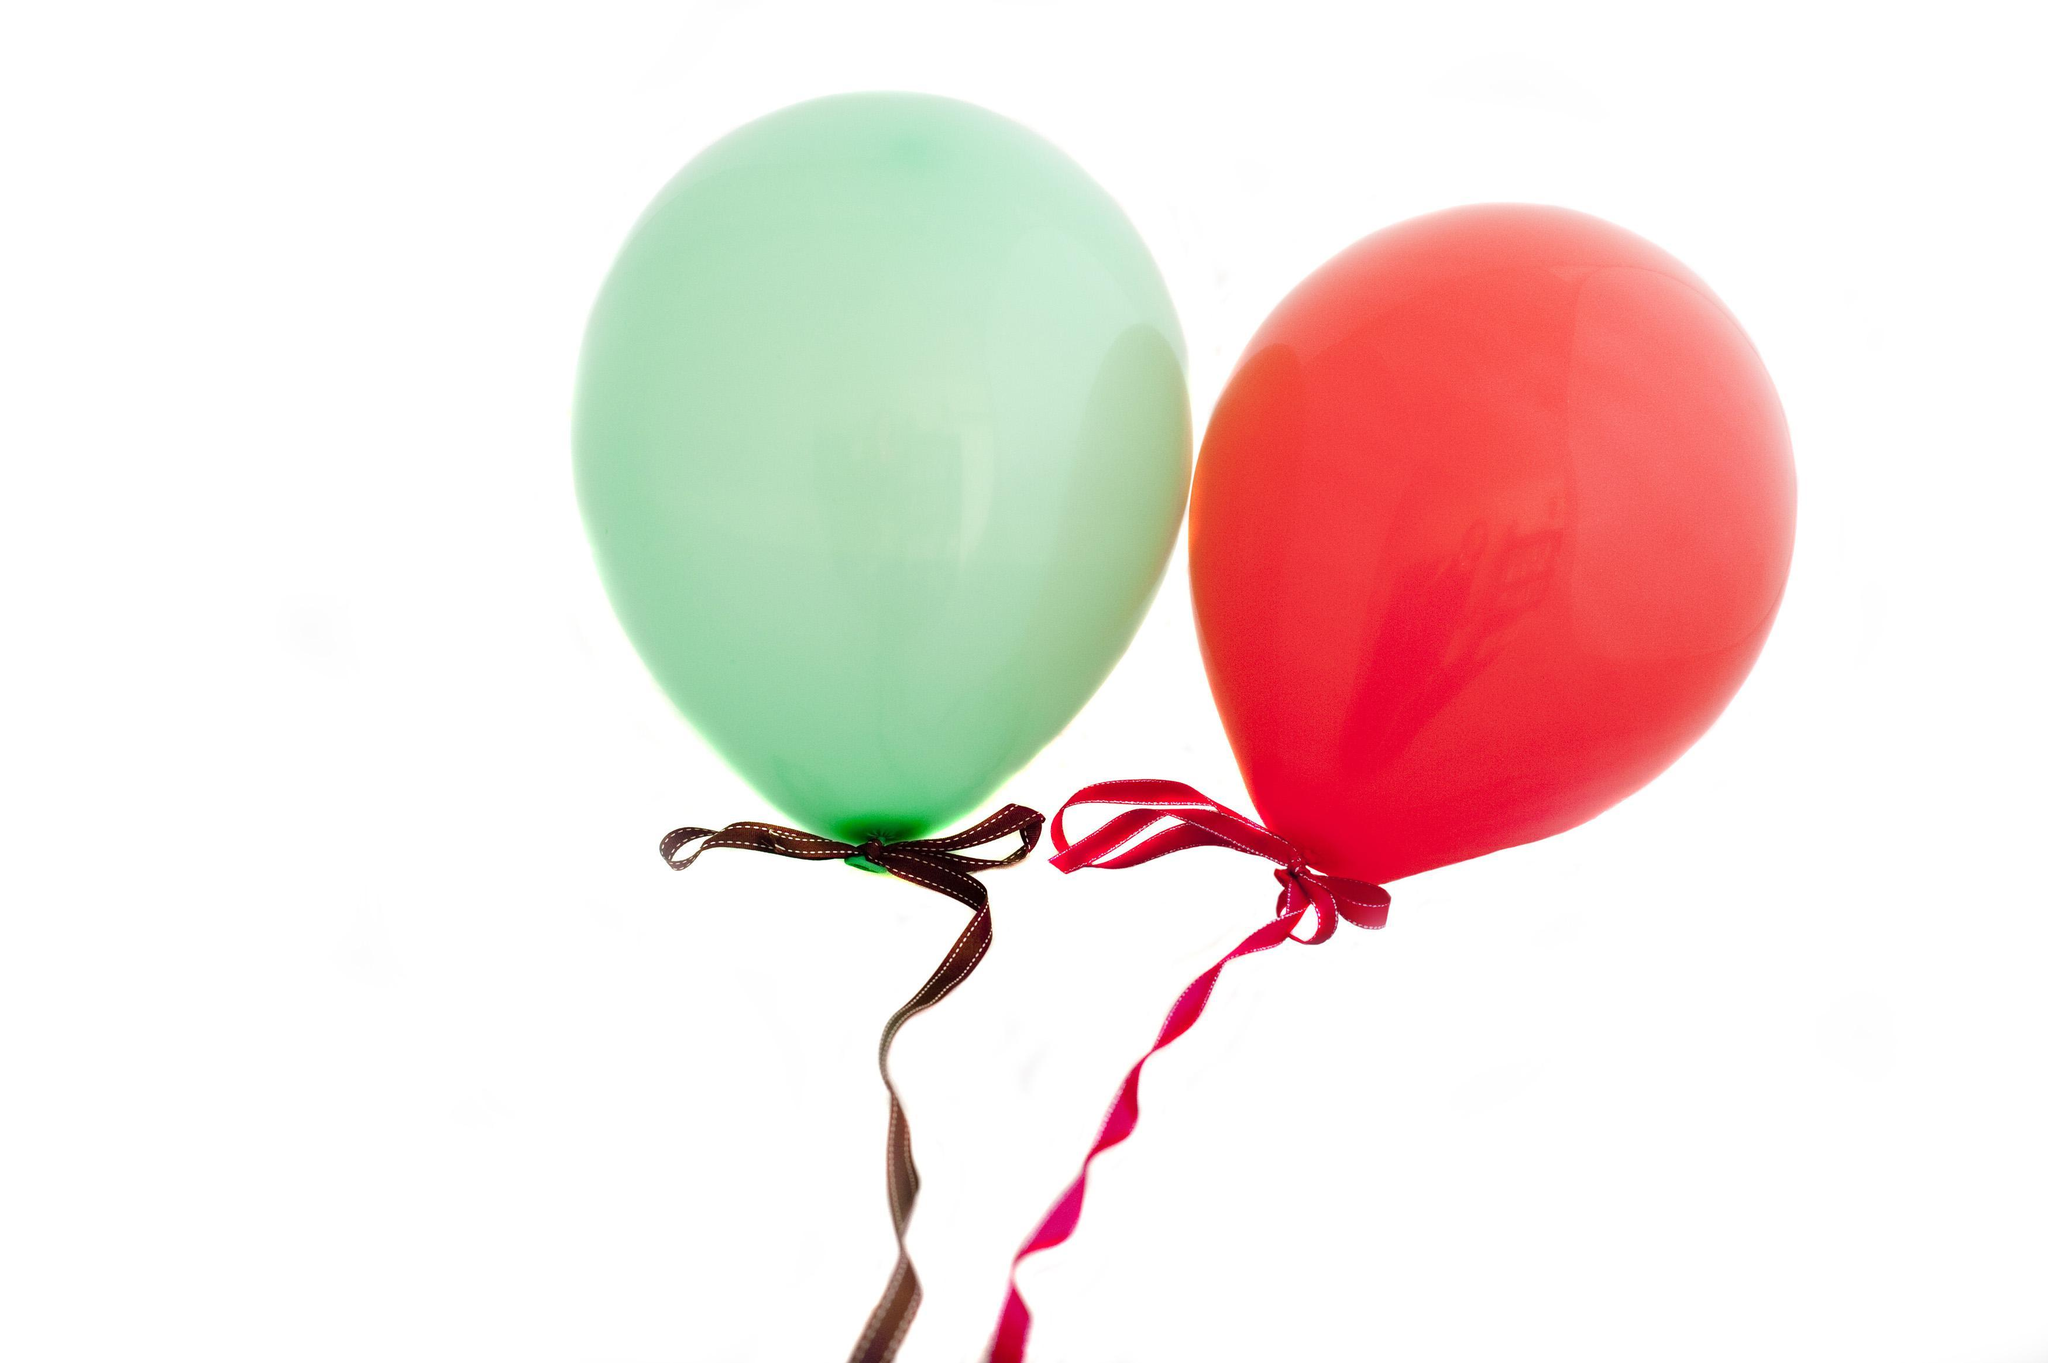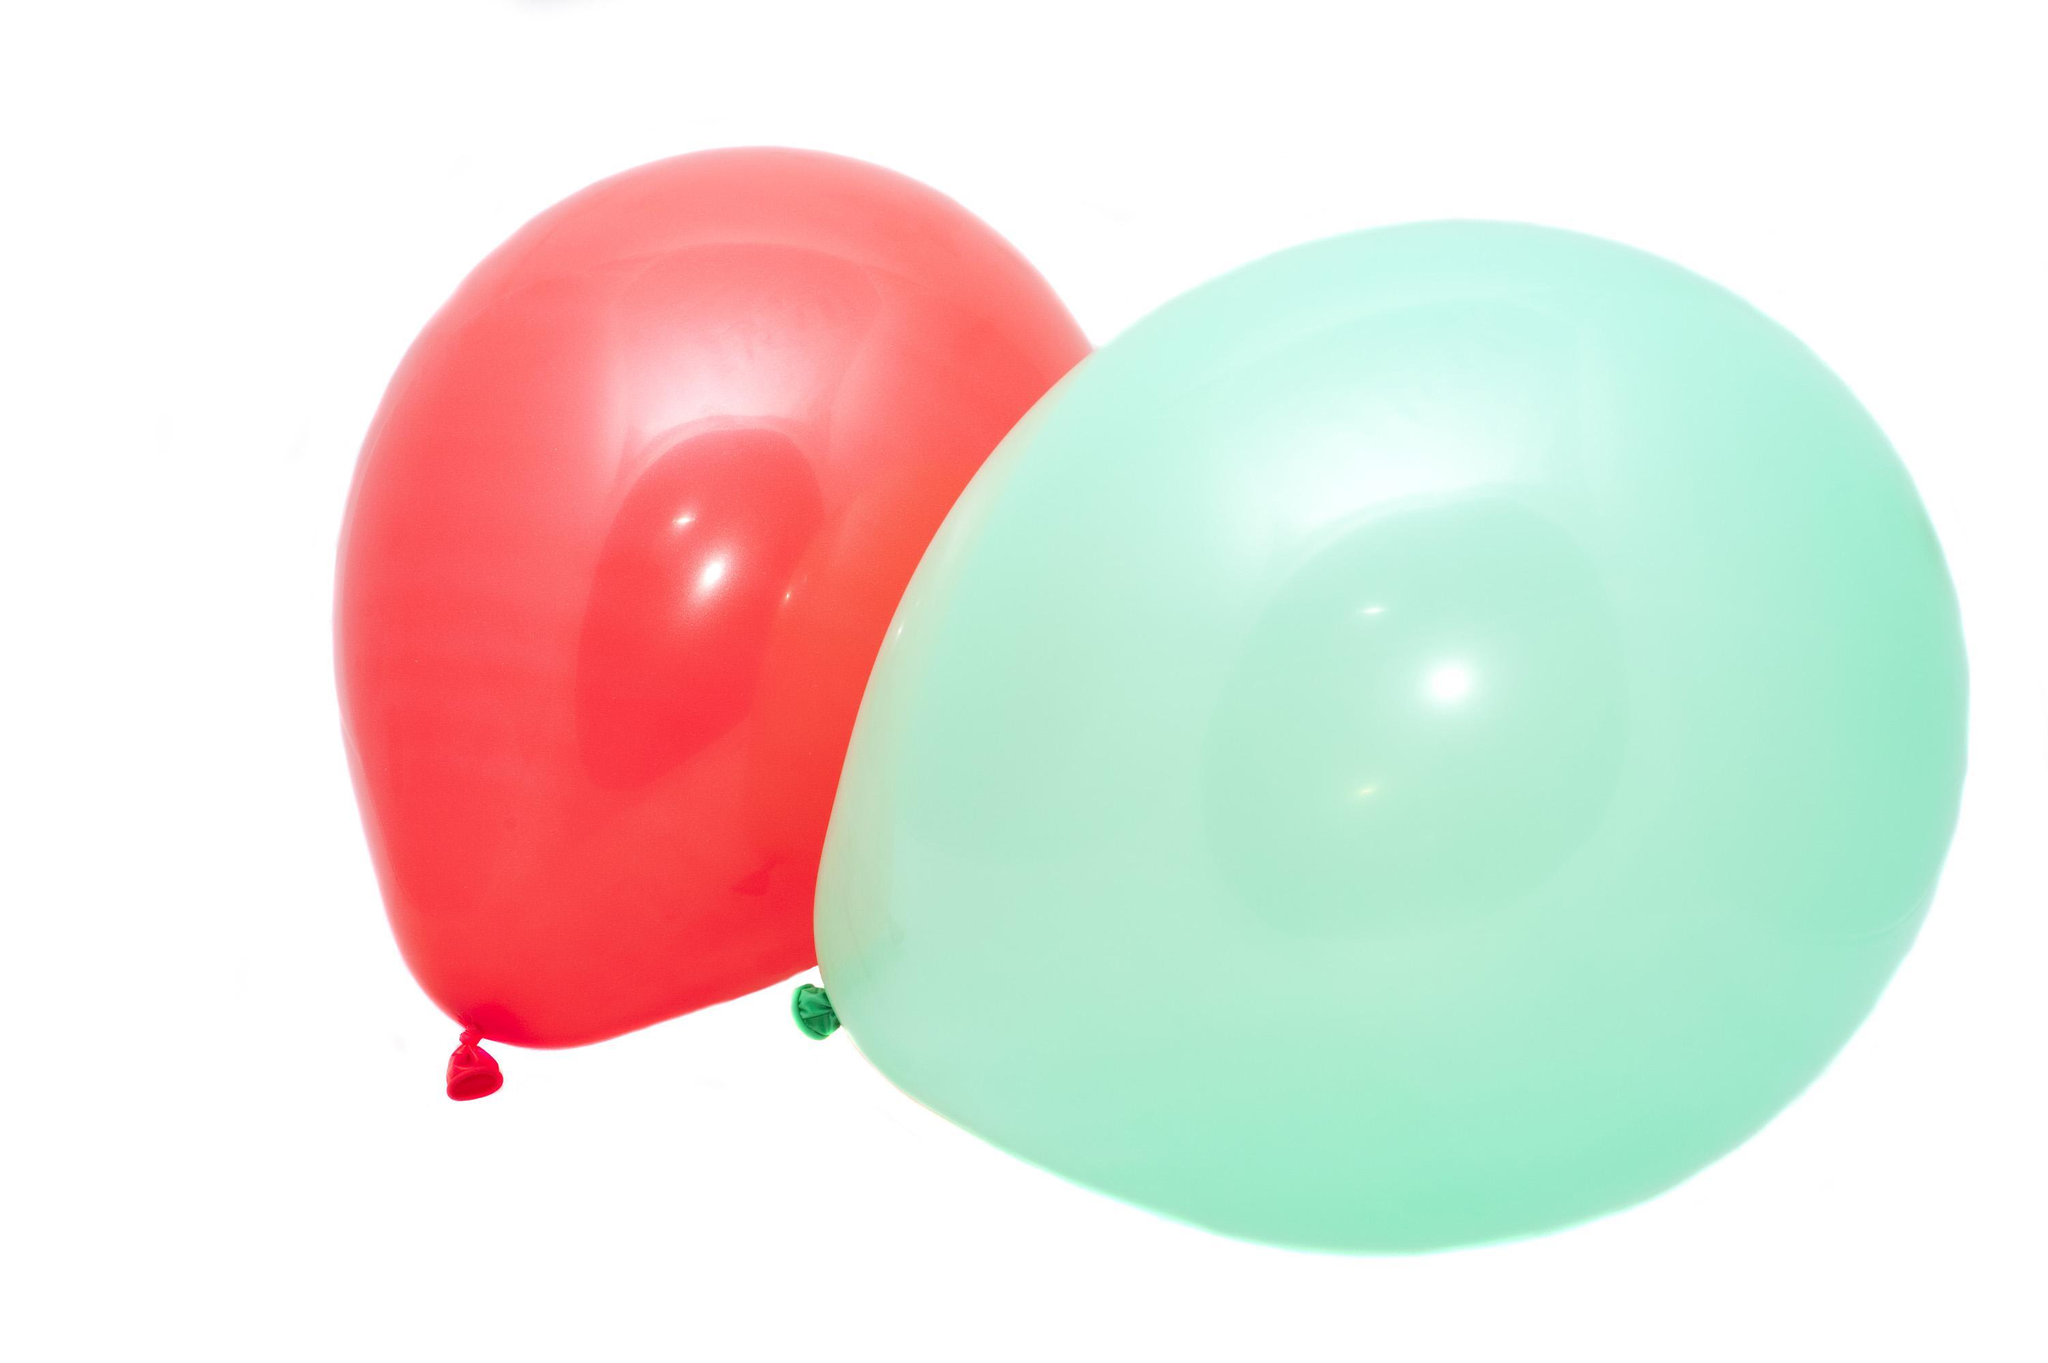The first image is the image on the left, the second image is the image on the right. For the images displayed, is the sentence "There are two red balloons out of the four shown." factually correct? Answer yes or no. Yes. 